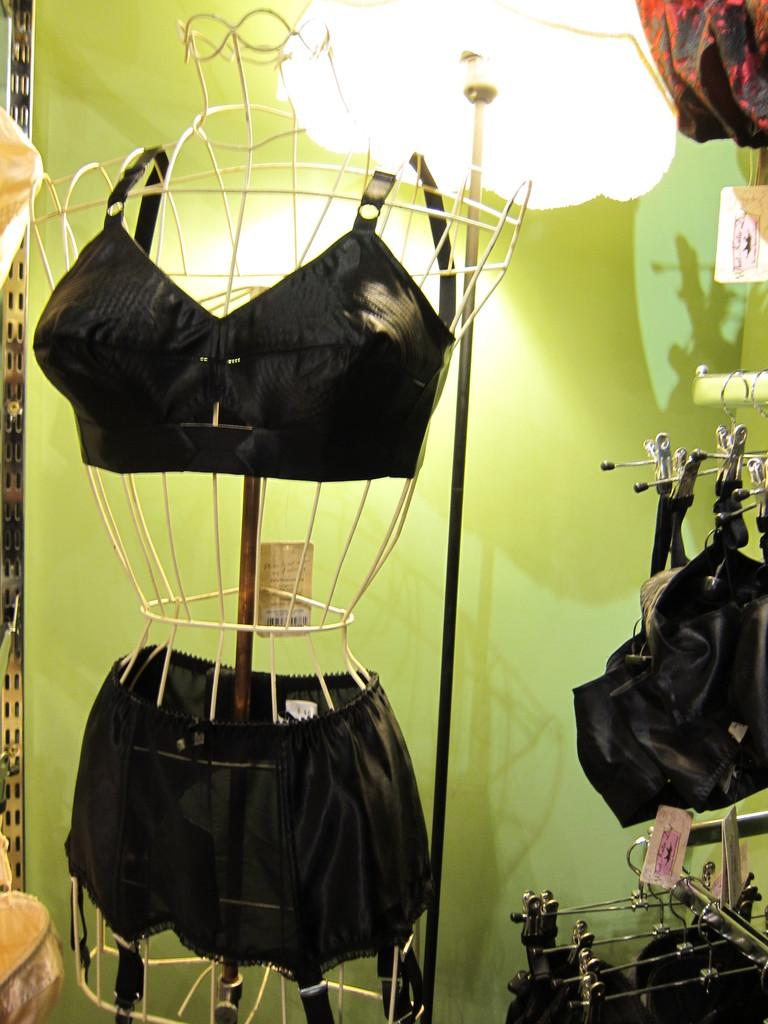What is on the object in the image? There is a dress on an object in the image. Where are the clothes located in the image? The clothes are on a rod on the right side of the image. What can be seen in the background of the image? There is a lamp and a wall in the background of the image. How many birds are perched on the dress in the image? There are no birds present in the image; it features a dress on an object and clothes on a rod. What type of quartz can be seen in the image? There is no quartz present in the image. 